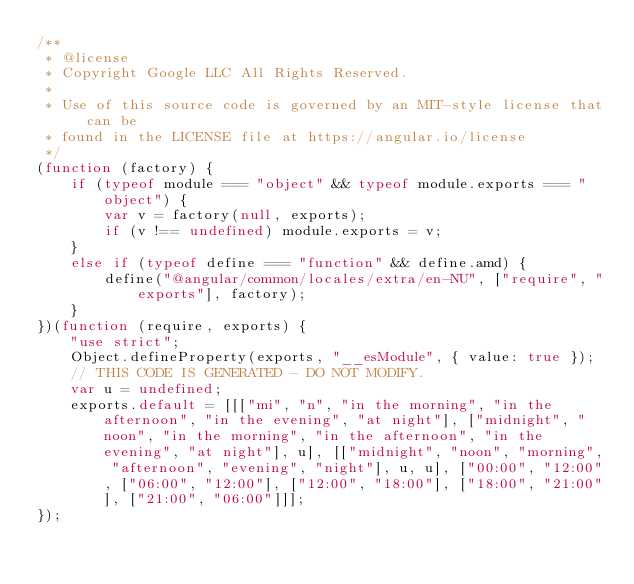Convert code to text. <code><loc_0><loc_0><loc_500><loc_500><_JavaScript_>/**
 * @license
 * Copyright Google LLC All Rights Reserved.
 *
 * Use of this source code is governed by an MIT-style license that can be
 * found in the LICENSE file at https://angular.io/license
 */
(function (factory) {
    if (typeof module === "object" && typeof module.exports === "object") {
        var v = factory(null, exports);
        if (v !== undefined) module.exports = v;
    }
    else if (typeof define === "function" && define.amd) {
        define("@angular/common/locales/extra/en-NU", ["require", "exports"], factory);
    }
})(function (require, exports) {
    "use strict";
    Object.defineProperty(exports, "__esModule", { value: true });
    // THIS CODE IS GENERATED - DO NOT MODIFY.
    var u = undefined;
    exports.default = [[["mi", "n", "in the morning", "in the afternoon", "in the evening", "at night"], ["midnight", "noon", "in the morning", "in the afternoon", "in the evening", "at night"], u], [["midnight", "noon", "morning", "afternoon", "evening", "night"], u, u], ["00:00", "12:00", ["06:00", "12:00"], ["12:00", "18:00"], ["18:00", "21:00"], ["21:00", "06:00"]]];
});</code> 